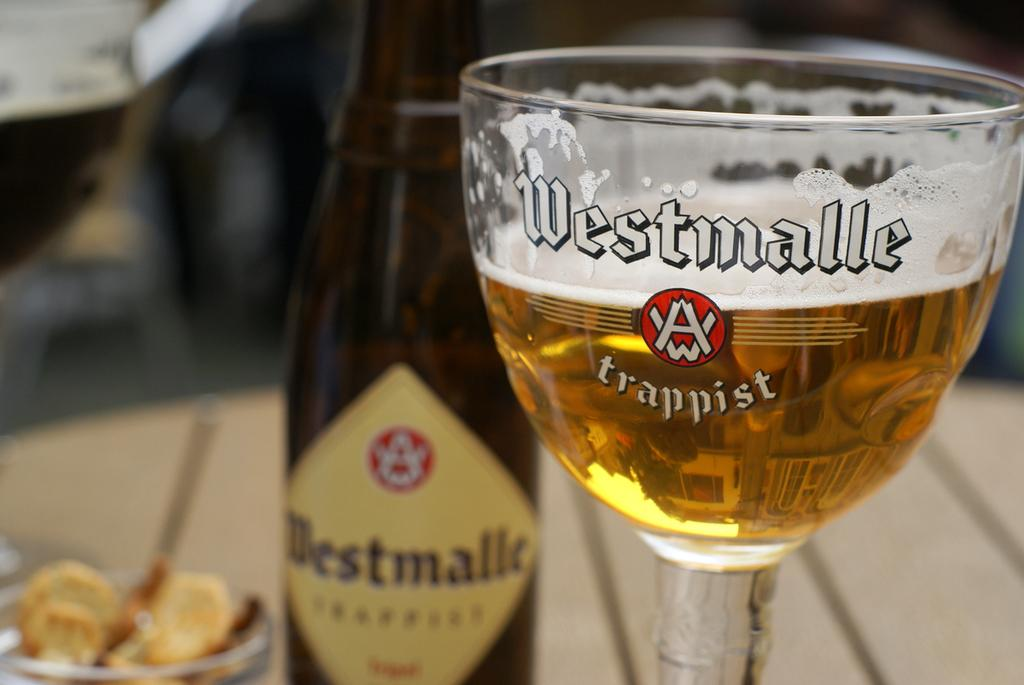<image>
Offer a succinct explanation of the picture presented. A bottle of Westmalle is next to a full glass with the same brand name on it. 